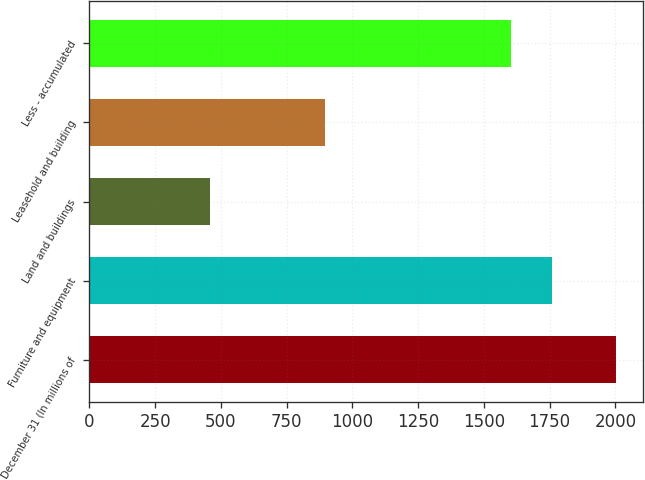<chart> <loc_0><loc_0><loc_500><loc_500><bar_chart><fcel>December 31 (In millions of<fcel>Furniture and equipment<fcel>Land and buildings<fcel>Leasehold and building<fcel>Less - accumulated<nl><fcel>2004<fcel>1757.7<fcel>457<fcel>897<fcel>1603<nl></chart> 